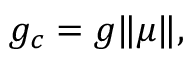Convert formula to latex. <formula><loc_0><loc_0><loc_500><loc_500>\begin{array} { r } { g _ { c } = g \| \mu \| , } \end{array}</formula> 